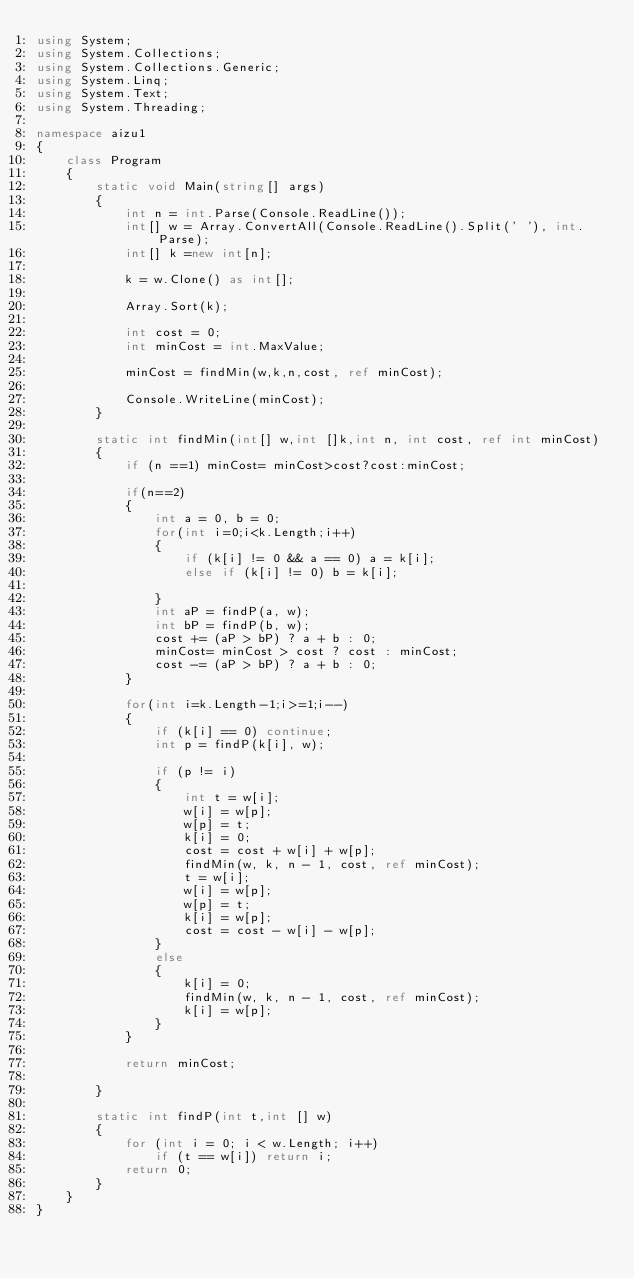Convert code to text. <code><loc_0><loc_0><loc_500><loc_500><_C#_>using System;
using System.Collections;
using System.Collections.Generic;
using System.Linq;
using System.Text;
using System.Threading;

namespace aizu1
{
    class Program
    {
        static void Main(string[] args)
        {
            int n = int.Parse(Console.ReadLine());
            int[] w = Array.ConvertAll(Console.ReadLine().Split(' '), int.Parse);
            int[] k =new int[n];

            k = w.Clone() as int[];

            Array.Sort(k);

            int cost = 0;
            int minCost = int.MaxValue;

            minCost = findMin(w,k,n,cost, ref minCost);

            Console.WriteLine(minCost);
        }

        static int findMin(int[] w,int []k,int n, int cost, ref int minCost)
        {
            if (n ==1) minCost= minCost>cost?cost:minCost;

            if(n==2)
            {
                int a = 0, b = 0;
                for(int i=0;i<k.Length;i++)
                {
                    if (k[i] != 0 && a == 0) a = k[i];
                    else if (k[i] != 0) b = k[i];

                }
                int aP = findP(a, w);
                int bP = findP(b, w);
                cost += (aP > bP) ? a + b : 0;
                minCost= minCost > cost ? cost : minCost;
                cost -= (aP > bP) ? a + b : 0;
            }

            for(int i=k.Length-1;i>=1;i--)
            {
                if (k[i] == 0) continue;
                int p = findP(k[i], w);

                if (p != i)
                {
                    int t = w[i];
                    w[i] = w[p];
                    w[p] = t;
                    k[i] = 0;
                    cost = cost + w[i] + w[p];
                    findMin(w, k, n - 1, cost, ref minCost);
                    t = w[i];
                    w[i] = w[p];
                    w[p] = t;
                    k[i] = w[p];
                    cost = cost - w[i] - w[p];
                }
                else
                {
                    k[i] = 0;
                    findMin(w, k, n - 1, cost, ref minCost);
                    k[i] = w[p];
                }
            }

            return minCost;
            
        }

        static int findP(int t,int [] w)
        {
            for (int i = 0; i < w.Length; i++)
                if (t == w[i]) return i;
            return 0;
        }
    }
}</code> 